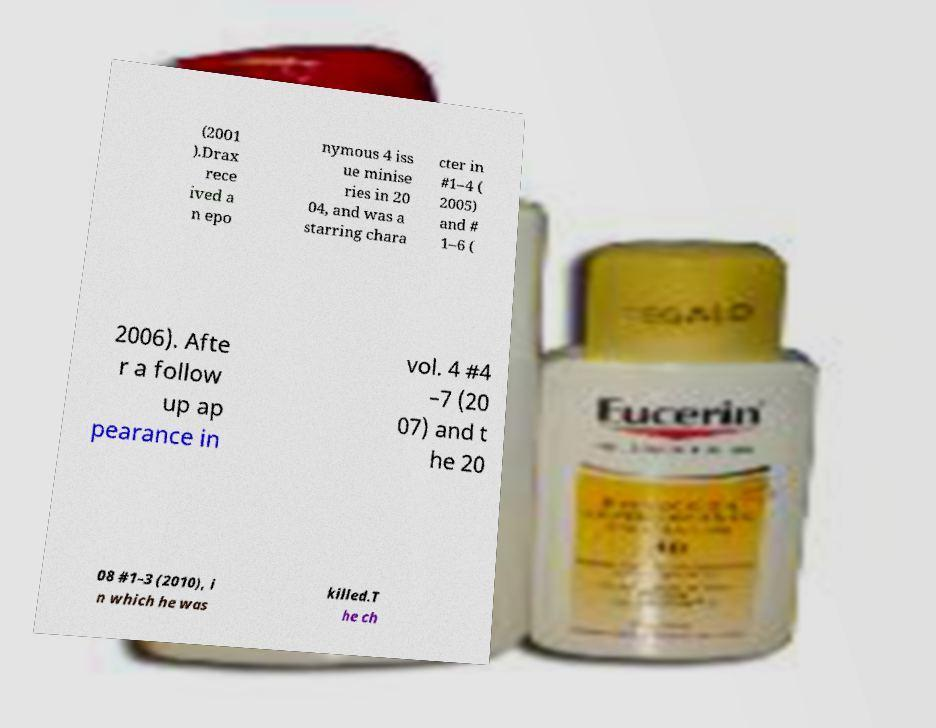I need the written content from this picture converted into text. Can you do that? (2001 ).Drax rece ived a n epo nymous 4 iss ue minise ries in 20 04, and was a starring chara cter in #1–4 ( 2005) and # 1–6 ( 2006). Afte r a follow up ap pearance in vol. 4 #4 –7 (20 07) and t he 20 08 #1–3 (2010), i n which he was killed.T he ch 